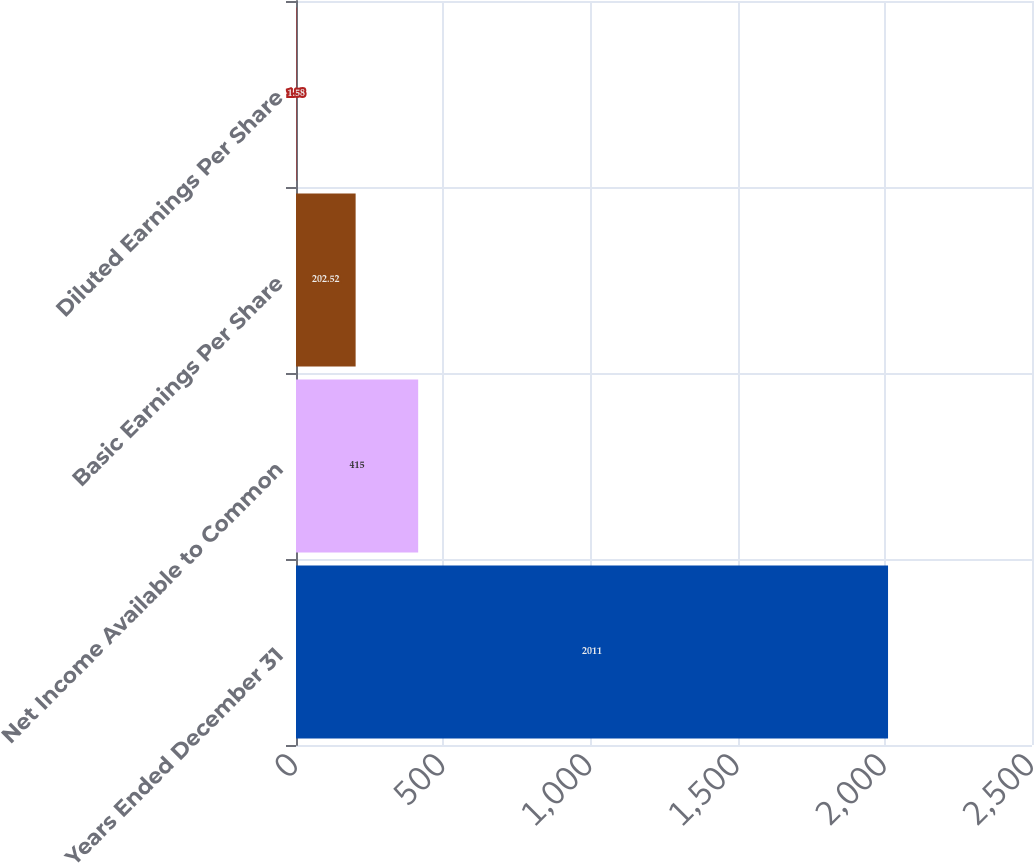Convert chart to OTSL. <chart><loc_0><loc_0><loc_500><loc_500><bar_chart><fcel>Years Ended December 31<fcel>Net Income Available to Common<fcel>Basic Earnings Per Share<fcel>Diluted Earnings Per Share<nl><fcel>2011<fcel>415<fcel>202.52<fcel>1.58<nl></chart> 